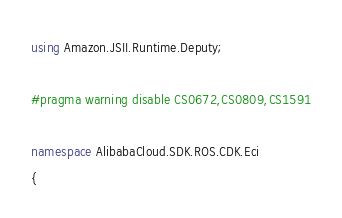<code> <loc_0><loc_0><loc_500><loc_500><_C#_>using Amazon.JSII.Runtime.Deputy;

#pragma warning disable CS0672,CS0809,CS1591

namespace AlibabaCloud.SDK.ROS.CDK.Eci
{</code> 